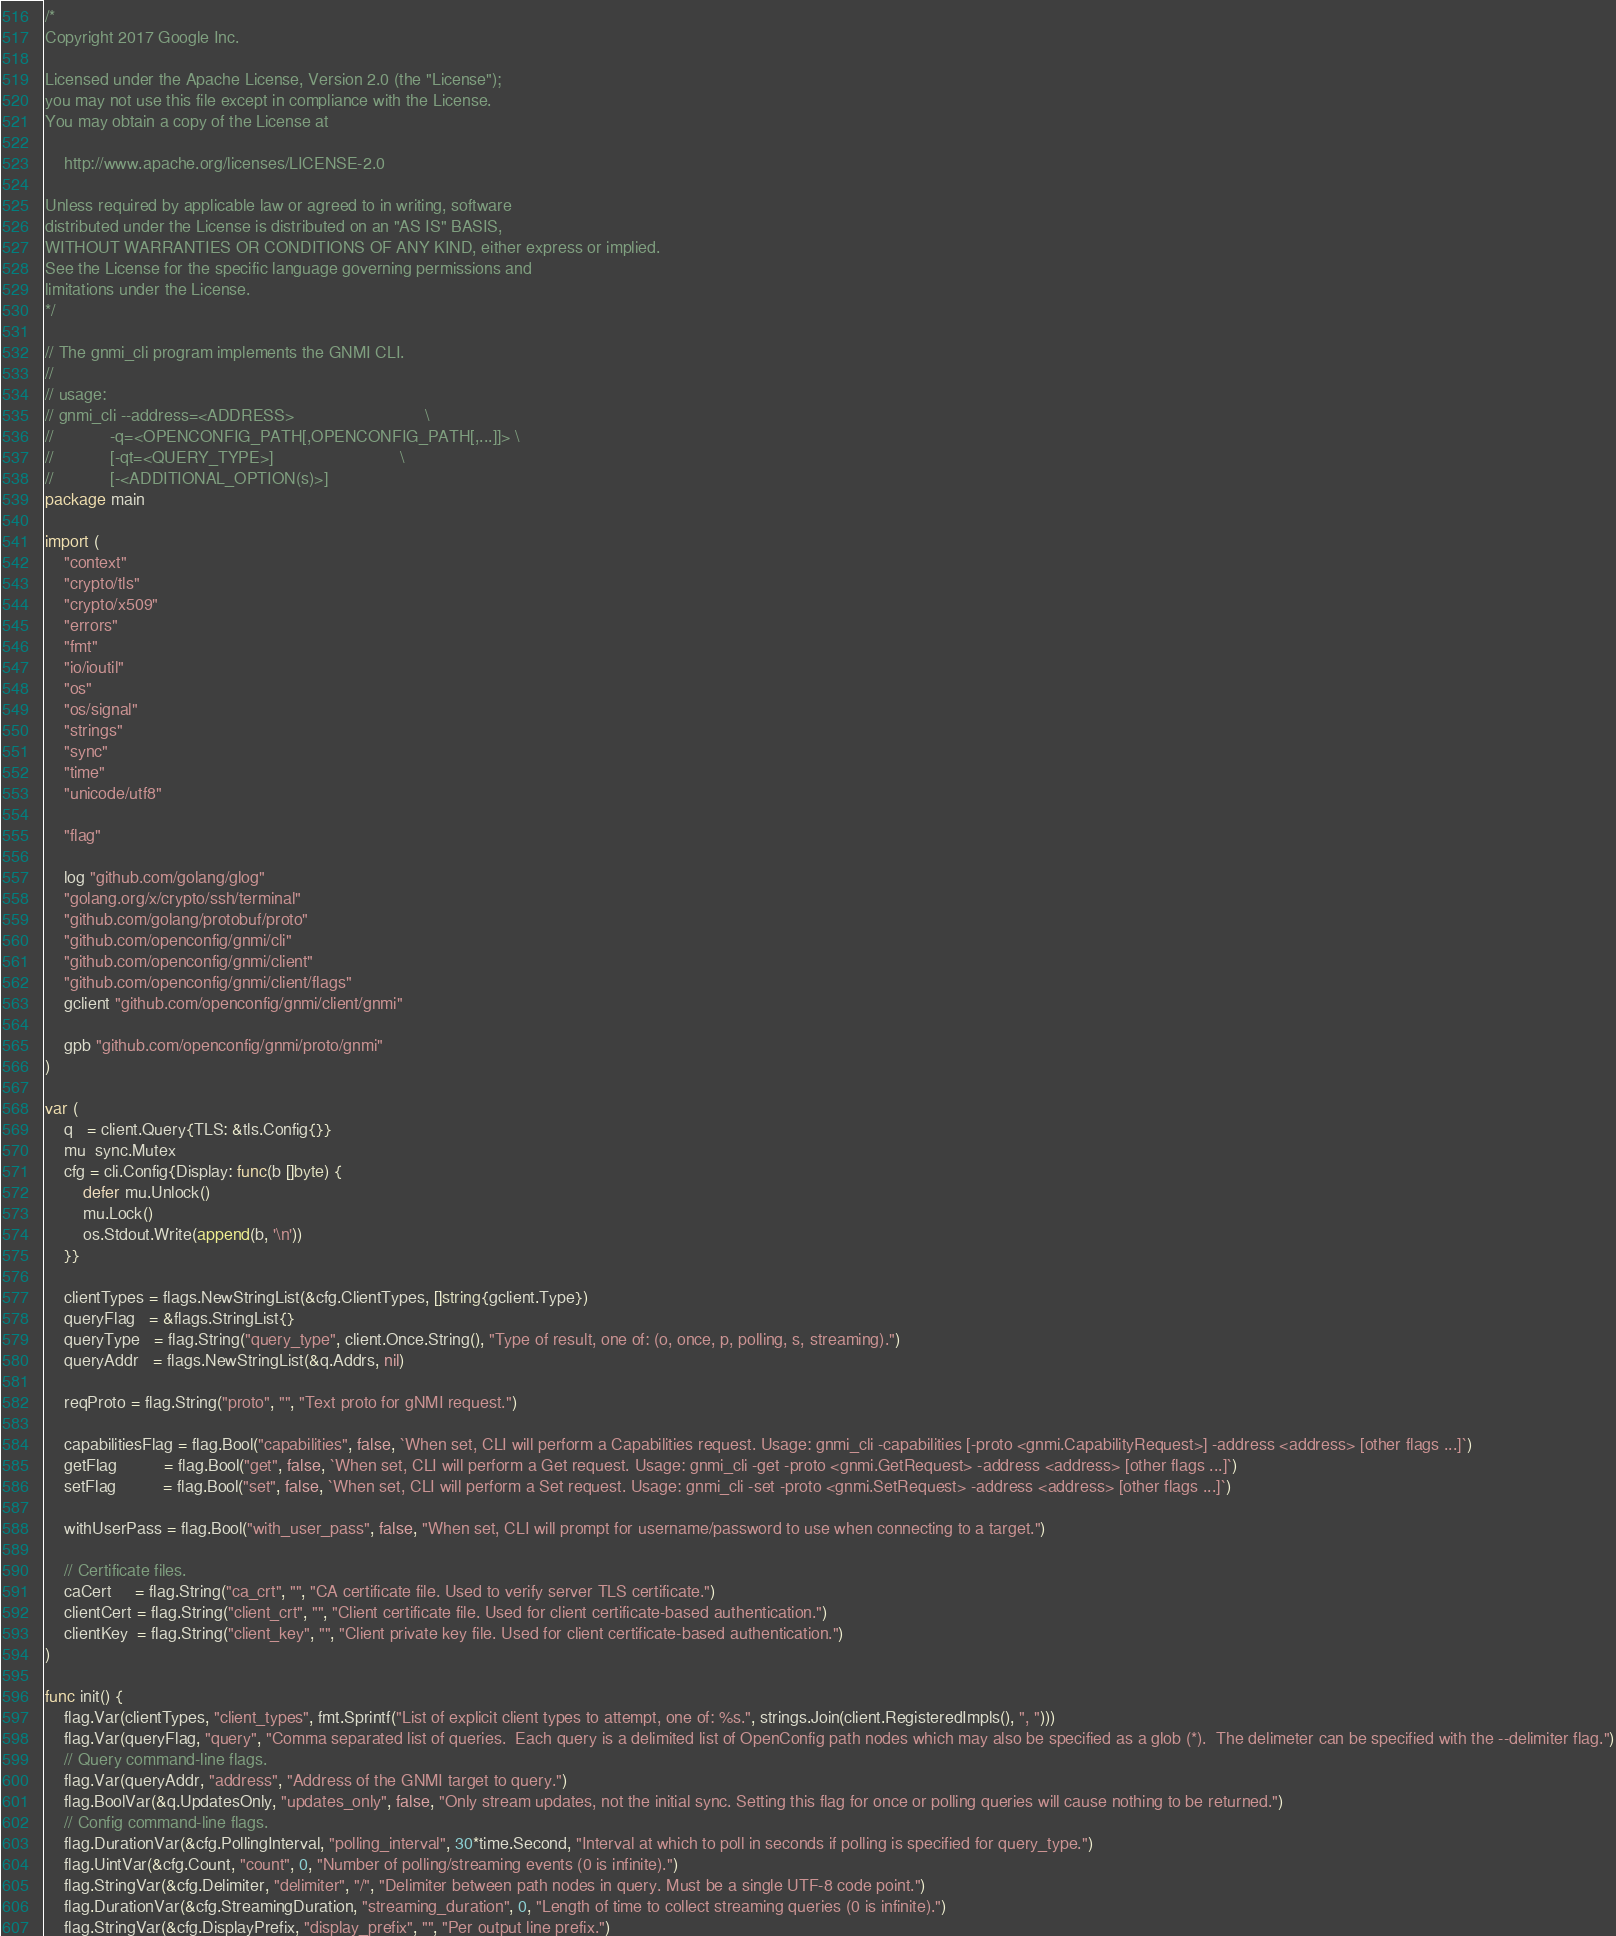<code> <loc_0><loc_0><loc_500><loc_500><_Go_>/*
Copyright 2017 Google Inc.

Licensed under the Apache License, Version 2.0 (the "License");
you may not use this file except in compliance with the License.
You may obtain a copy of the License at

    http://www.apache.org/licenses/LICENSE-2.0

Unless required by applicable law or agreed to in writing, software
distributed under the License is distributed on an "AS IS" BASIS,
WITHOUT WARRANTIES OR CONDITIONS OF ANY KIND, either express or implied.
See the License for the specific language governing permissions and
limitations under the License.
*/

// The gnmi_cli program implements the GNMI CLI.
//
// usage:
// gnmi_cli --address=<ADDRESS>                            \
//            -q=<OPENCONFIG_PATH[,OPENCONFIG_PATH[,...]]> \
//            [-qt=<QUERY_TYPE>]                           \
//            [-<ADDITIONAL_OPTION(s)>]
package main

import (
	"context"
	"crypto/tls"
	"crypto/x509"
	"errors"
	"fmt"
	"io/ioutil"
	"os"
	"os/signal"
	"strings"
	"sync"
	"time"
	"unicode/utf8"

	"flag"
	
	log "github.com/golang/glog"
	"golang.org/x/crypto/ssh/terminal"
	"github.com/golang/protobuf/proto"
	"github.com/openconfig/gnmi/cli"
	"github.com/openconfig/gnmi/client"
	"github.com/openconfig/gnmi/client/flags"
	gclient "github.com/openconfig/gnmi/client/gnmi"

	gpb "github.com/openconfig/gnmi/proto/gnmi"
)

var (
	q   = client.Query{TLS: &tls.Config{}}
	mu  sync.Mutex
	cfg = cli.Config{Display: func(b []byte) {
		defer mu.Unlock()
		mu.Lock()
		os.Stdout.Write(append(b, '\n'))
	}}

	clientTypes = flags.NewStringList(&cfg.ClientTypes, []string{gclient.Type})
	queryFlag   = &flags.StringList{}
	queryType   = flag.String("query_type", client.Once.String(), "Type of result, one of: (o, once, p, polling, s, streaming).")
	queryAddr   = flags.NewStringList(&q.Addrs, nil)

	reqProto = flag.String("proto", "", "Text proto for gNMI request.")

	capabilitiesFlag = flag.Bool("capabilities", false, `When set, CLI will perform a Capabilities request. Usage: gnmi_cli -capabilities [-proto <gnmi.CapabilityRequest>] -address <address> [other flags ...]`)
	getFlag          = flag.Bool("get", false, `When set, CLI will perform a Get request. Usage: gnmi_cli -get -proto <gnmi.GetRequest> -address <address> [other flags ...]`)
	setFlag          = flag.Bool("set", false, `When set, CLI will perform a Set request. Usage: gnmi_cli -set -proto <gnmi.SetRequest> -address <address> [other flags ...]`)

	withUserPass = flag.Bool("with_user_pass", false, "When set, CLI will prompt for username/password to use when connecting to a target.")

	// Certificate files.
	caCert     = flag.String("ca_crt", "", "CA certificate file. Used to verify server TLS certificate.")
	clientCert = flag.String("client_crt", "", "Client certificate file. Used for client certificate-based authentication.")
	clientKey  = flag.String("client_key", "", "Client private key file. Used for client certificate-based authentication.")
)

func init() {
	flag.Var(clientTypes, "client_types", fmt.Sprintf("List of explicit client types to attempt, one of: %s.", strings.Join(client.RegisteredImpls(), ", ")))
	flag.Var(queryFlag, "query", "Comma separated list of queries.  Each query is a delimited list of OpenConfig path nodes which may also be specified as a glob (*).  The delimeter can be specified with the --delimiter flag.")
	// Query command-line flags.
	flag.Var(queryAddr, "address", "Address of the GNMI target to query.")
	flag.BoolVar(&q.UpdatesOnly, "updates_only", false, "Only stream updates, not the initial sync. Setting this flag for once or polling queries will cause nothing to be returned.")
	// Config command-line flags.
	flag.DurationVar(&cfg.PollingInterval, "polling_interval", 30*time.Second, "Interval at which to poll in seconds if polling is specified for query_type.")
	flag.UintVar(&cfg.Count, "count", 0, "Number of polling/streaming events (0 is infinite).")
	flag.StringVar(&cfg.Delimiter, "delimiter", "/", "Delimiter between path nodes in query. Must be a single UTF-8 code point.")
	flag.DurationVar(&cfg.StreamingDuration, "streaming_duration", 0, "Length of time to collect streaming queries (0 is infinite).")
	flag.StringVar(&cfg.DisplayPrefix, "display_prefix", "", "Per output line prefix.")</code> 